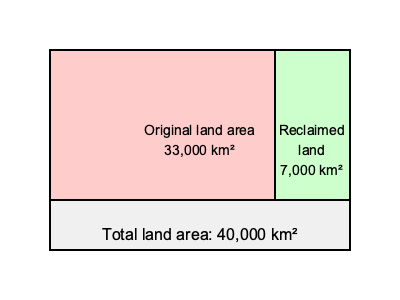As a loyal supporter of the Dutch royal family, you're proud of the Netherlands' land reclamation efforts. Given that the original land area of the Netherlands was 33,000 km² and the total land area after reclamation projects is 40,000 km², what percentage increase in land area has been achieved through these projects? To calculate the percentage increase in land area, we'll follow these steps:

1. Calculate the amount of reclaimed land:
   Total land area after reclamation - Original land area
   $40,000 \text{ km}^2 - 33,000 \text{ km}^2 = 7,000 \text{ km}^2$

2. Calculate the percentage increase:
   $\text{Percentage increase} = \frac{\text{Increase in land area}}{\text{Original land area}} \times 100\%$

   $\text{Percentage increase} = \frac{7,000 \text{ km}^2}{33,000 \text{ km}^2} \times 100\%$

3. Simplify the fraction:
   $\frac{7,000}{33,000} = \frac{7}{33}$

4. Perform the division and multiply by 100%:
   $\frac{7}{33} \approx 0.2121$
   $0.2121 \times 100\% \approx 21.21\%$

Therefore, the percentage increase in land area achieved through land reclamation projects is approximately 21.21%.
Answer: 21.21% 